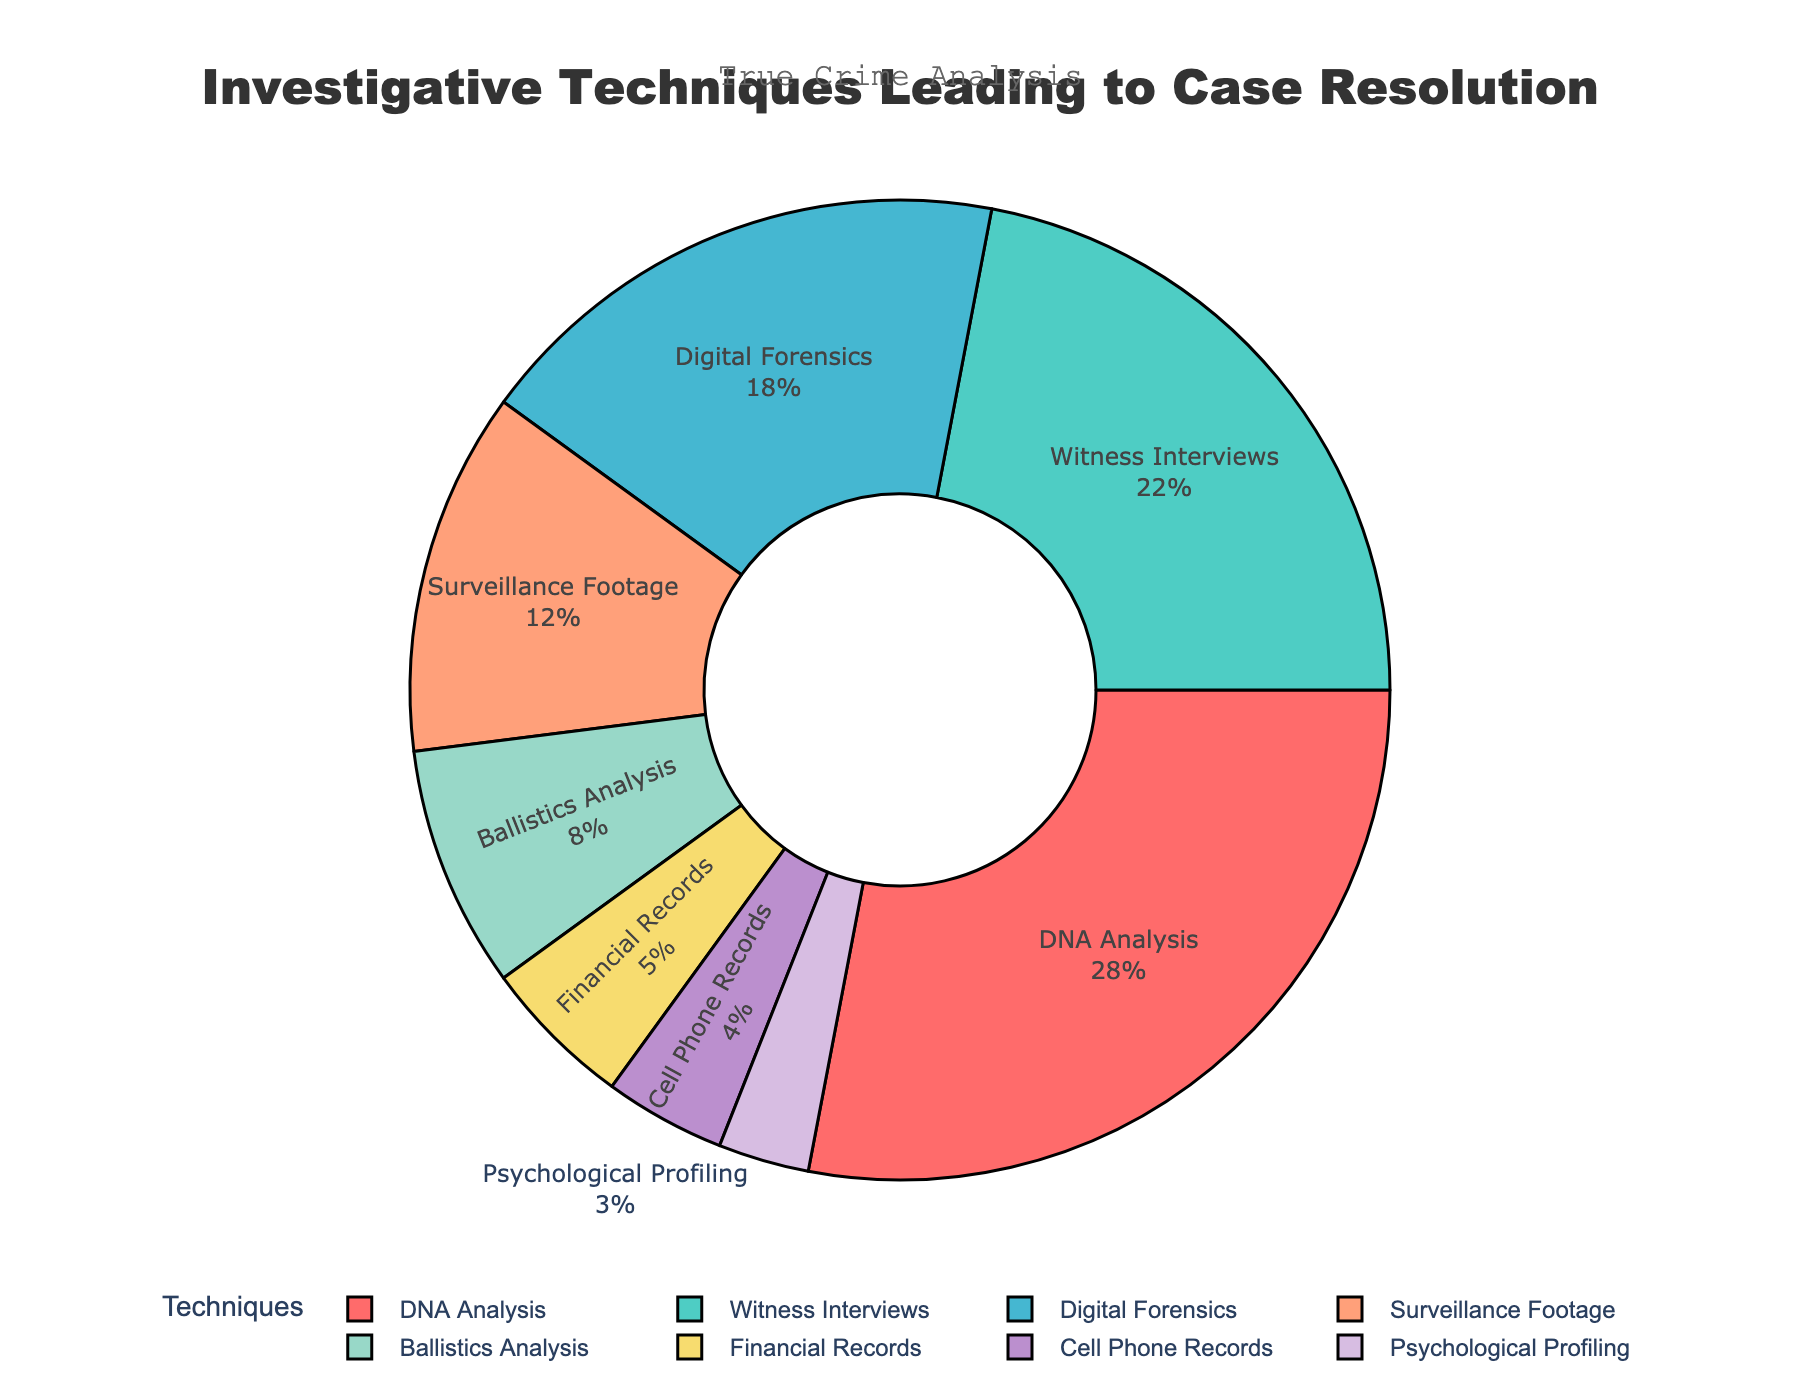How many techniques have a percentage greater than 10%? Check each technique's percentage and count those greater than 10%: DNA Analysis (28%), Witness Interviews (22%), Digital Forensics (18%), and Surveillance Footage (12%). This gives us a total of 4 techniques.
Answer: 4 Which two techniques together account for the highest percentage of case resolutions? Identify the top two percentages: DNA Analysis (28%) and Witness Interviews (22%). Their combined percentage is 28% + 22% = 50%.
Answer: DNA Analysis and Witness Interviews How much higher is the percentage of DNA Analysis than Financial Records? Subtract the percentage of Financial Records (5%) from DNA Analysis (28%): 28% - 5% = 23%.
Answer: 23% Which technique has the smallest percentage, and what is it? Look for the technique with the lowest percentage: Psychological Profiling at 3%.
Answer: Psychological Profiling, 3% What is the combined percentage of Digital Forensics, Ballistics Analysis, and Cell Phone Records? Add the percentages: Digital Forensics (18%) + Ballistics Analysis (8%) + Cell Phone Records (4%) = 18% + 8% + 4% = 30%.
Answer: 30% Which investigative technique accounts for 12%? Find the technique with a 12% value: Surveillance Footage.
Answer: Surveillance Footage How much greater is the sum of Surveillance Footage and Witness Interviews compared to Financial Records and Cell Phone Records? Calculate the sums: Surveillance Footage (12%) + Witness Interviews (22%) = 34%, Financial Records (5%) + Cell Phone Records (4%) = 9%. Difference is 34% - 9% = 25%.
Answer: 25% Are there any pairs of techniques that combined have a total percentage equal to that of DNA Analysis? If yes, which ones? Check combinations summing to 28%. Witness Interviews (22%) + Ballistics Analysis (8%) = 30%, Digital Forensics (18%) + Financial Records (5%) = 23%, etc. No pairs sum exactly to 28%.
Answer: No What percentage of cases are resolved by the four least used techniques combined? Sum the percentages of Ballistics Analysis (8%), Financial Records (5%), Cell Phone Records (4%), and Psychological Profiling (3%): 8% + 5% + 4% + 3% = 20%.
Answer: 20% Which color represents the technique that accounts for 3% of case resolutions? Look for the color associated with Psychological Profiling (3%), which uses the color closest to the eighth listed color, which is a shade of purple.
Answer: Purple 